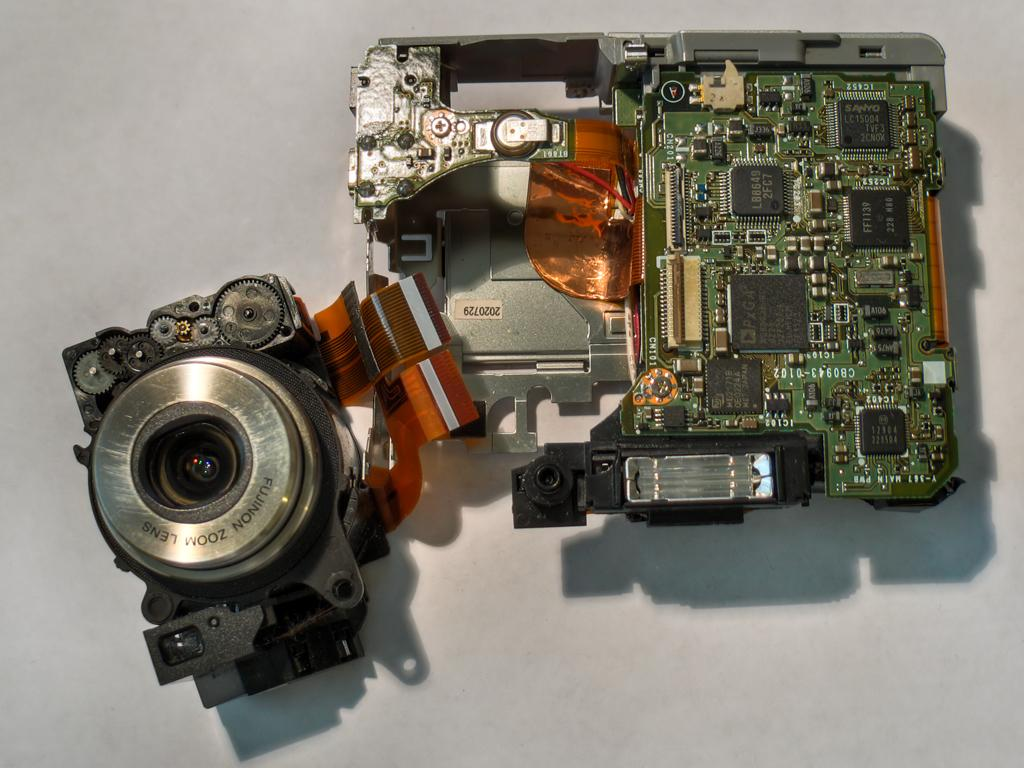What is the main subject in the center of the image? There is an object in the center of the image. Can you describe the object in the image? Unfortunately, the provided facts do not give enough information to describe the object. Where is the object located? The object is on a surface. How many pies are being baked in the image? There is no indication of pies or baking in the image. What decision is being made by the object in the image? There is not enough information provided to determine if a decision is being made by the object in the image. 